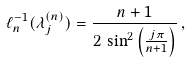Convert formula to latex. <formula><loc_0><loc_0><loc_500><loc_500>\ell _ { n } ^ { - 1 } ( \lambda _ { j } ^ { ( n ) } ) = \frac { n + 1 } { 2 \, \sin ^ { 2 } \left ( \frac { j \pi } { n + 1 } \right ) } \, ,</formula> 